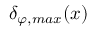Convert formula to latex. <formula><loc_0><loc_0><loc_500><loc_500>\delta _ { \varphi , \max } ( x )</formula> 